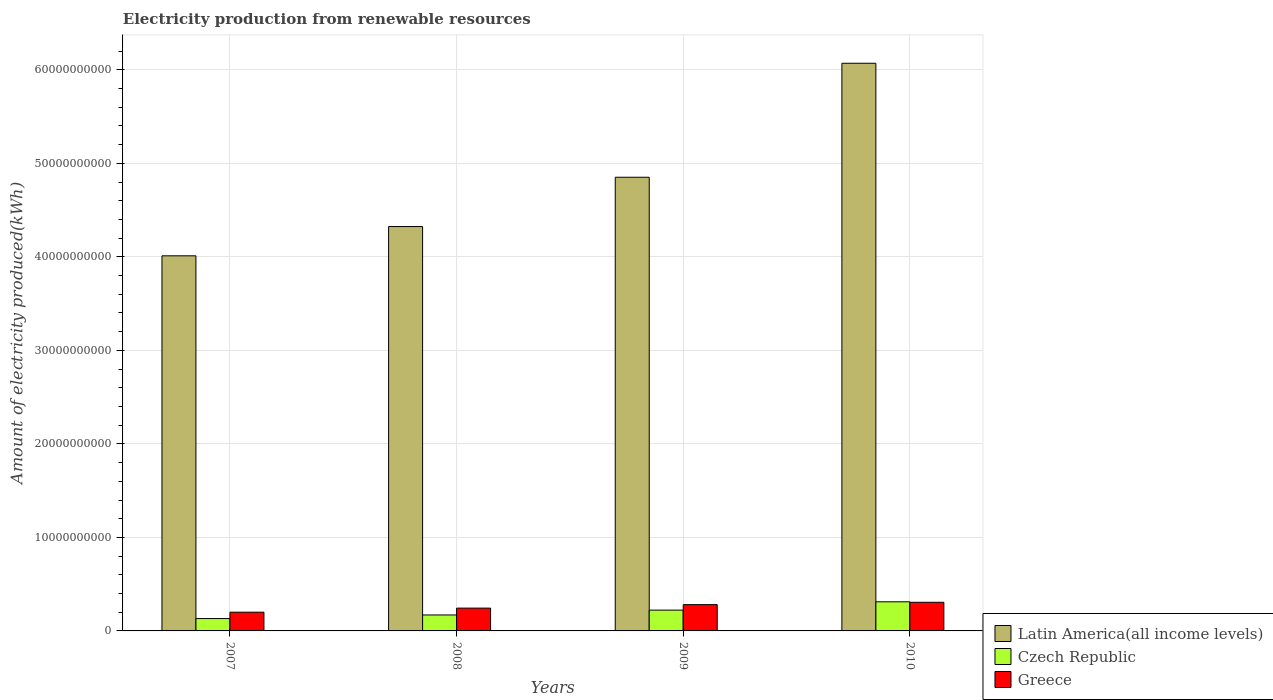How many groups of bars are there?
Provide a short and direct response. 4. Are the number of bars on each tick of the X-axis equal?
Make the answer very short. Yes. How many bars are there on the 1st tick from the right?
Give a very brief answer. 3. What is the label of the 2nd group of bars from the left?
Your answer should be very brief. 2008. What is the amount of electricity produced in Latin America(all income levels) in 2007?
Ensure brevity in your answer.  4.01e+1. Across all years, what is the maximum amount of electricity produced in Latin America(all income levels)?
Provide a succinct answer. 6.07e+1. Across all years, what is the minimum amount of electricity produced in Greece?
Provide a short and direct response. 2.00e+09. In which year was the amount of electricity produced in Czech Republic minimum?
Your response must be concise. 2007. What is the total amount of electricity produced in Greece in the graph?
Ensure brevity in your answer.  1.03e+1. What is the difference between the amount of electricity produced in Greece in 2007 and that in 2010?
Give a very brief answer. -1.06e+09. What is the difference between the amount of electricity produced in Czech Republic in 2008 and the amount of electricity produced in Greece in 2010?
Offer a very short reply. -1.36e+09. What is the average amount of electricity produced in Greece per year?
Ensure brevity in your answer.  2.58e+09. In the year 2009, what is the difference between the amount of electricity produced in Latin America(all income levels) and amount of electricity produced in Greece?
Keep it short and to the point. 4.57e+1. In how many years, is the amount of electricity produced in Latin America(all income levels) greater than 60000000000 kWh?
Your response must be concise. 1. What is the ratio of the amount of electricity produced in Czech Republic in 2008 to that in 2009?
Your response must be concise. 0.77. Is the difference between the amount of electricity produced in Latin America(all income levels) in 2007 and 2009 greater than the difference between the amount of electricity produced in Greece in 2007 and 2009?
Your response must be concise. No. What is the difference between the highest and the second highest amount of electricity produced in Latin America(all income levels)?
Your answer should be very brief. 1.22e+1. What is the difference between the highest and the lowest amount of electricity produced in Czech Republic?
Provide a succinct answer. 1.79e+09. In how many years, is the amount of electricity produced in Latin America(all income levels) greater than the average amount of electricity produced in Latin America(all income levels) taken over all years?
Keep it short and to the point. 2. What does the 3rd bar from the left in 2009 represents?
Your answer should be compact. Greece. What does the 3rd bar from the right in 2008 represents?
Make the answer very short. Latin America(all income levels). How many years are there in the graph?
Make the answer very short. 4. What is the difference between two consecutive major ticks on the Y-axis?
Offer a very short reply. 1.00e+1. Are the values on the major ticks of Y-axis written in scientific E-notation?
Provide a short and direct response. No. Does the graph contain any zero values?
Provide a succinct answer. No. Does the graph contain grids?
Ensure brevity in your answer.  Yes. How many legend labels are there?
Provide a succinct answer. 3. How are the legend labels stacked?
Offer a very short reply. Vertical. What is the title of the graph?
Provide a succinct answer. Electricity production from renewable resources. Does "Mauritania" appear as one of the legend labels in the graph?
Make the answer very short. No. What is the label or title of the X-axis?
Your answer should be compact. Years. What is the label or title of the Y-axis?
Ensure brevity in your answer.  Amount of electricity produced(kWh). What is the Amount of electricity produced(kWh) in Latin America(all income levels) in 2007?
Offer a very short reply. 4.01e+1. What is the Amount of electricity produced(kWh) of Czech Republic in 2007?
Keep it short and to the point. 1.32e+09. What is the Amount of electricity produced(kWh) in Greece in 2007?
Ensure brevity in your answer.  2.00e+09. What is the Amount of electricity produced(kWh) in Latin America(all income levels) in 2008?
Keep it short and to the point. 4.32e+1. What is the Amount of electricity produced(kWh) in Czech Republic in 2008?
Keep it short and to the point. 1.71e+09. What is the Amount of electricity produced(kWh) of Greece in 2008?
Your answer should be compact. 2.44e+09. What is the Amount of electricity produced(kWh) of Latin America(all income levels) in 2009?
Provide a succinct answer. 4.85e+1. What is the Amount of electricity produced(kWh) in Czech Republic in 2009?
Your response must be concise. 2.22e+09. What is the Amount of electricity produced(kWh) of Greece in 2009?
Offer a very short reply. 2.81e+09. What is the Amount of electricity produced(kWh) in Latin America(all income levels) in 2010?
Ensure brevity in your answer.  6.07e+1. What is the Amount of electricity produced(kWh) in Czech Republic in 2010?
Offer a very short reply. 3.11e+09. What is the Amount of electricity produced(kWh) in Greece in 2010?
Provide a succinct answer. 3.06e+09. Across all years, what is the maximum Amount of electricity produced(kWh) in Latin America(all income levels)?
Provide a succinct answer. 6.07e+1. Across all years, what is the maximum Amount of electricity produced(kWh) of Czech Republic?
Provide a short and direct response. 3.11e+09. Across all years, what is the maximum Amount of electricity produced(kWh) in Greece?
Ensure brevity in your answer.  3.06e+09. Across all years, what is the minimum Amount of electricity produced(kWh) of Latin America(all income levels)?
Give a very brief answer. 4.01e+1. Across all years, what is the minimum Amount of electricity produced(kWh) in Czech Republic?
Make the answer very short. 1.32e+09. Across all years, what is the minimum Amount of electricity produced(kWh) of Greece?
Your response must be concise. 2.00e+09. What is the total Amount of electricity produced(kWh) of Latin America(all income levels) in the graph?
Keep it short and to the point. 1.93e+11. What is the total Amount of electricity produced(kWh) in Czech Republic in the graph?
Your answer should be very brief. 8.37e+09. What is the total Amount of electricity produced(kWh) in Greece in the graph?
Your answer should be very brief. 1.03e+1. What is the difference between the Amount of electricity produced(kWh) of Latin America(all income levels) in 2007 and that in 2008?
Offer a terse response. -3.13e+09. What is the difference between the Amount of electricity produced(kWh) of Czech Republic in 2007 and that in 2008?
Give a very brief answer. -3.86e+08. What is the difference between the Amount of electricity produced(kWh) in Greece in 2007 and that in 2008?
Offer a very short reply. -4.35e+08. What is the difference between the Amount of electricity produced(kWh) in Latin America(all income levels) in 2007 and that in 2009?
Your response must be concise. -8.40e+09. What is the difference between the Amount of electricity produced(kWh) of Czech Republic in 2007 and that in 2009?
Give a very brief answer. -9.04e+08. What is the difference between the Amount of electricity produced(kWh) in Greece in 2007 and that in 2009?
Offer a very short reply. -8.08e+08. What is the difference between the Amount of electricity produced(kWh) of Latin America(all income levels) in 2007 and that in 2010?
Give a very brief answer. -2.06e+1. What is the difference between the Amount of electricity produced(kWh) of Czech Republic in 2007 and that in 2010?
Offer a very short reply. -1.79e+09. What is the difference between the Amount of electricity produced(kWh) of Greece in 2007 and that in 2010?
Provide a succinct answer. -1.06e+09. What is the difference between the Amount of electricity produced(kWh) of Latin America(all income levels) in 2008 and that in 2009?
Make the answer very short. -5.27e+09. What is the difference between the Amount of electricity produced(kWh) in Czech Republic in 2008 and that in 2009?
Provide a short and direct response. -5.18e+08. What is the difference between the Amount of electricity produced(kWh) in Greece in 2008 and that in 2009?
Provide a short and direct response. -3.73e+08. What is the difference between the Amount of electricity produced(kWh) in Latin America(all income levels) in 2008 and that in 2010?
Ensure brevity in your answer.  -1.75e+1. What is the difference between the Amount of electricity produced(kWh) of Czech Republic in 2008 and that in 2010?
Keep it short and to the point. -1.41e+09. What is the difference between the Amount of electricity produced(kWh) in Greece in 2008 and that in 2010?
Give a very brief answer. -6.24e+08. What is the difference between the Amount of electricity produced(kWh) in Latin America(all income levels) in 2009 and that in 2010?
Offer a terse response. -1.22e+1. What is the difference between the Amount of electricity produced(kWh) of Czech Republic in 2009 and that in 2010?
Your response must be concise. -8.88e+08. What is the difference between the Amount of electricity produced(kWh) in Greece in 2009 and that in 2010?
Ensure brevity in your answer.  -2.51e+08. What is the difference between the Amount of electricity produced(kWh) in Latin America(all income levels) in 2007 and the Amount of electricity produced(kWh) in Czech Republic in 2008?
Give a very brief answer. 3.84e+1. What is the difference between the Amount of electricity produced(kWh) in Latin America(all income levels) in 2007 and the Amount of electricity produced(kWh) in Greece in 2008?
Provide a short and direct response. 3.77e+1. What is the difference between the Amount of electricity produced(kWh) of Czech Republic in 2007 and the Amount of electricity produced(kWh) of Greece in 2008?
Keep it short and to the point. -1.12e+09. What is the difference between the Amount of electricity produced(kWh) of Latin America(all income levels) in 2007 and the Amount of electricity produced(kWh) of Czech Republic in 2009?
Give a very brief answer. 3.79e+1. What is the difference between the Amount of electricity produced(kWh) in Latin America(all income levels) in 2007 and the Amount of electricity produced(kWh) in Greece in 2009?
Make the answer very short. 3.73e+1. What is the difference between the Amount of electricity produced(kWh) of Czech Republic in 2007 and the Amount of electricity produced(kWh) of Greece in 2009?
Keep it short and to the point. -1.49e+09. What is the difference between the Amount of electricity produced(kWh) of Latin America(all income levels) in 2007 and the Amount of electricity produced(kWh) of Czech Republic in 2010?
Provide a succinct answer. 3.70e+1. What is the difference between the Amount of electricity produced(kWh) of Latin America(all income levels) in 2007 and the Amount of electricity produced(kWh) of Greece in 2010?
Give a very brief answer. 3.70e+1. What is the difference between the Amount of electricity produced(kWh) of Czech Republic in 2007 and the Amount of electricity produced(kWh) of Greece in 2010?
Ensure brevity in your answer.  -1.74e+09. What is the difference between the Amount of electricity produced(kWh) of Latin America(all income levels) in 2008 and the Amount of electricity produced(kWh) of Czech Republic in 2009?
Your response must be concise. 4.10e+1. What is the difference between the Amount of electricity produced(kWh) of Latin America(all income levels) in 2008 and the Amount of electricity produced(kWh) of Greece in 2009?
Provide a short and direct response. 4.04e+1. What is the difference between the Amount of electricity produced(kWh) of Czech Republic in 2008 and the Amount of electricity produced(kWh) of Greece in 2009?
Ensure brevity in your answer.  -1.10e+09. What is the difference between the Amount of electricity produced(kWh) in Latin America(all income levels) in 2008 and the Amount of electricity produced(kWh) in Czech Republic in 2010?
Offer a terse response. 4.01e+1. What is the difference between the Amount of electricity produced(kWh) of Latin America(all income levels) in 2008 and the Amount of electricity produced(kWh) of Greece in 2010?
Ensure brevity in your answer.  4.02e+1. What is the difference between the Amount of electricity produced(kWh) in Czech Republic in 2008 and the Amount of electricity produced(kWh) in Greece in 2010?
Offer a terse response. -1.36e+09. What is the difference between the Amount of electricity produced(kWh) in Latin America(all income levels) in 2009 and the Amount of electricity produced(kWh) in Czech Republic in 2010?
Your answer should be very brief. 4.54e+1. What is the difference between the Amount of electricity produced(kWh) in Latin America(all income levels) in 2009 and the Amount of electricity produced(kWh) in Greece in 2010?
Your answer should be very brief. 4.55e+1. What is the difference between the Amount of electricity produced(kWh) in Czech Republic in 2009 and the Amount of electricity produced(kWh) in Greece in 2010?
Your answer should be very brief. -8.37e+08. What is the average Amount of electricity produced(kWh) in Latin America(all income levels) per year?
Provide a short and direct response. 4.81e+1. What is the average Amount of electricity produced(kWh) of Czech Republic per year?
Provide a short and direct response. 2.09e+09. What is the average Amount of electricity produced(kWh) of Greece per year?
Your answer should be very brief. 2.58e+09. In the year 2007, what is the difference between the Amount of electricity produced(kWh) in Latin America(all income levels) and Amount of electricity produced(kWh) in Czech Republic?
Your response must be concise. 3.88e+1. In the year 2007, what is the difference between the Amount of electricity produced(kWh) of Latin America(all income levels) and Amount of electricity produced(kWh) of Greece?
Give a very brief answer. 3.81e+1. In the year 2007, what is the difference between the Amount of electricity produced(kWh) of Czech Republic and Amount of electricity produced(kWh) of Greece?
Ensure brevity in your answer.  -6.82e+08. In the year 2008, what is the difference between the Amount of electricity produced(kWh) in Latin America(all income levels) and Amount of electricity produced(kWh) in Czech Republic?
Give a very brief answer. 4.15e+1. In the year 2008, what is the difference between the Amount of electricity produced(kWh) in Latin America(all income levels) and Amount of electricity produced(kWh) in Greece?
Offer a terse response. 4.08e+1. In the year 2008, what is the difference between the Amount of electricity produced(kWh) in Czech Republic and Amount of electricity produced(kWh) in Greece?
Ensure brevity in your answer.  -7.31e+08. In the year 2009, what is the difference between the Amount of electricity produced(kWh) in Latin America(all income levels) and Amount of electricity produced(kWh) in Czech Republic?
Offer a very short reply. 4.63e+1. In the year 2009, what is the difference between the Amount of electricity produced(kWh) in Latin America(all income levels) and Amount of electricity produced(kWh) in Greece?
Offer a terse response. 4.57e+1. In the year 2009, what is the difference between the Amount of electricity produced(kWh) in Czech Republic and Amount of electricity produced(kWh) in Greece?
Your answer should be very brief. -5.86e+08. In the year 2010, what is the difference between the Amount of electricity produced(kWh) in Latin America(all income levels) and Amount of electricity produced(kWh) in Czech Republic?
Provide a succinct answer. 5.76e+1. In the year 2010, what is the difference between the Amount of electricity produced(kWh) in Latin America(all income levels) and Amount of electricity produced(kWh) in Greece?
Keep it short and to the point. 5.76e+1. In the year 2010, what is the difference between the Amount of electricity produced(kWh) of Czech Republic and Amount of electricity produced(kWh) of Greece?
Keep it short and to the point. 5.10e+07. What is the ratio of the Amount of electricity produced(kWh) in Latin America(all income levels) in 2007 to that in 2008?
Make the answer very short. 0.93. What is the ratio of the Amount of electricity produced(kWh) in Czech Republic in 2007 to that in 2008?
Your answer should be very brief. 0.77. What is the ratio of the Amount of electricity produced(kWh) in Greece in 2007 to that in 2008?
Ensure brevity in your answer.  0.82. What is the ratio of the Amount of electricity produced(kWh) in Latin America(all income levels) in 2007 to that in 2009?
Keep it short and to the point. 0.83. What is the ratio of the Amount of electricity produced(kWh) in Czech Republic in 2007 to that in 2009?
Provide a succinct answer. 0.59. What is the ratio of the Amount of electricity produced(kWh) in Greece in 2007 to that in 2009?
Keep it short and to the point. 0.71. What is the ratio of the Amount of electricity produced(kWh) of Latin America(all income levels) in 2007 to that in 2010?
Provide a succinct answer. 0.66. What is the ratio of the Amount of electricity produced(kWh) of Czech Republic in 2007 to that in 2010?
Provide a short and direct response. 0.42. What is the ratio of the Amount of electricity produced(kWh) in Greece in 2007 to that in 2010?
Ensure brevity in your answer.  0.65. What is the ratio of the Amount of electricity produced(kWh) in Latin America(all income levels) in 2008 to that in 2009?
Offer a very short reply. 0.89. What is the ratio of the Amount of electricity produced(kWh) of Czech Republic in 2008 to that in 2009?
Your answer should be compact. 0.77. What is the ratio of the Amount of electricity produced(kWh) in Greece in 2008 to that in 2009?
Your answer should be very brief. 0.87. What is the ratio of the Amount of electricity produced(kWh) of Latin America(all income levels) in 2008 to that in 2010?
Make the answer very short. 0.71. What is the ratio of the Amount of electricity produced(kWh) in Czech Republic in 2008 to that in 2010?
Keep it short and to the point. 0.55. What is the ratio of the Amount of electricity produced(kWh) of Greece in 2008 to that in 2010?
Your response must be concise. 0.8. What is the ratio of the Amount of electricity produced(kWh) of Latin America(all income levels) in 2009 to that in 2010?
Offer a terse response. 0.8. What is the ratio of the Amount of electricity produced(kWh) of Czech Republic in 2009 to that in 2010?
Offer a terse response. 0.71. What is the ratio of the Amount of electricity produced(kWh) in Greece in 2009 to that in 2010?
Your response must be concise. 0.92. What is the difference between the highest and the second highest Amount of electricity produced(kWh) in Latin America(all income levels)?
Your answer should be compact. 1.22e+1. What is the difference between the highest and the second highest Amount of electricity produced(kWh) of Czech Republic?
Your answer should be compact. 8.88e+08. What is the difference between the highest and the second highest Amount of electricity produced(kWh) in Greece?
Offer a very short reply. 2.51e+08. What is the difference between the highest and the lowest Amount of electricity produced(kWh) in Latin America(all income levels)?
Provide a succinct answer. 2.06e+1. What is the difference between the highest and the lowest Amount of electricity produced(kWh) of Czech Republic?
Offer a terse response. 1.79e+09. What is the difference between the highest and the lowest Amount of electricity produced(kWh) of Greece?
Your response must be concise. 1.06e+09. 